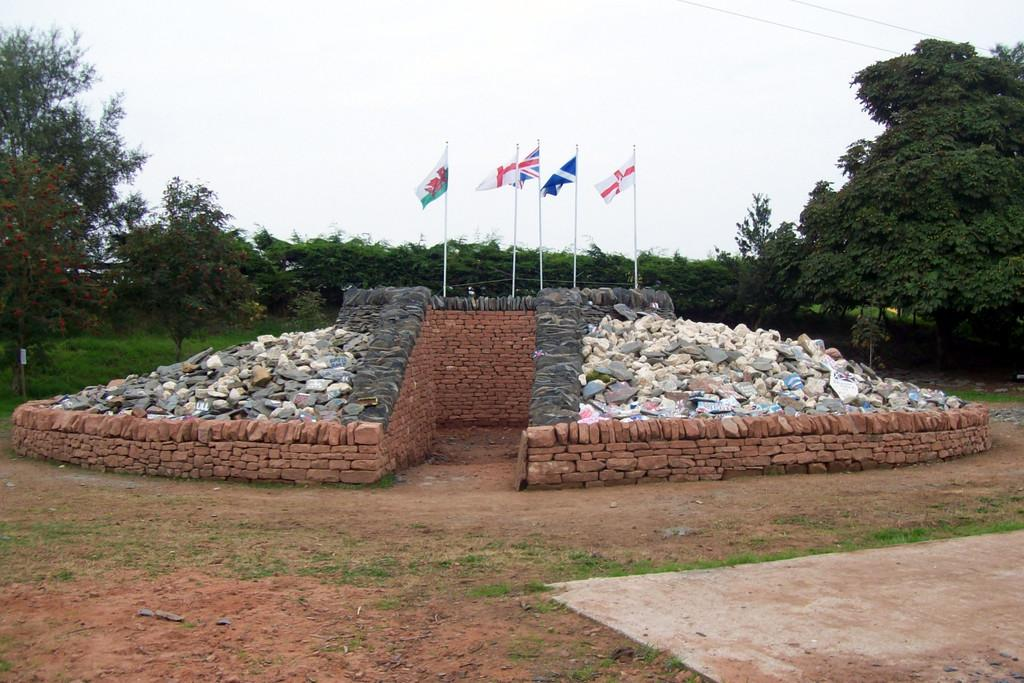How many flags are hanging on the wall in the image? There are five flags on the wall in the image. What can be seen on the left side of the image? There are many stones on the left side of the image. What type of vegetation is visible in the background of the image? There are plants, grass, and trees visible in the background of the image. What is visible at the top of the image? The sky is visible at the top of the image. What type of fruit can be smelled in the image? There is no fruit present in the image, so it cannot be smelled. What type of quince is growing on the trees in the background of the image? There is no quince present in the image; only trees are visible in the background. 